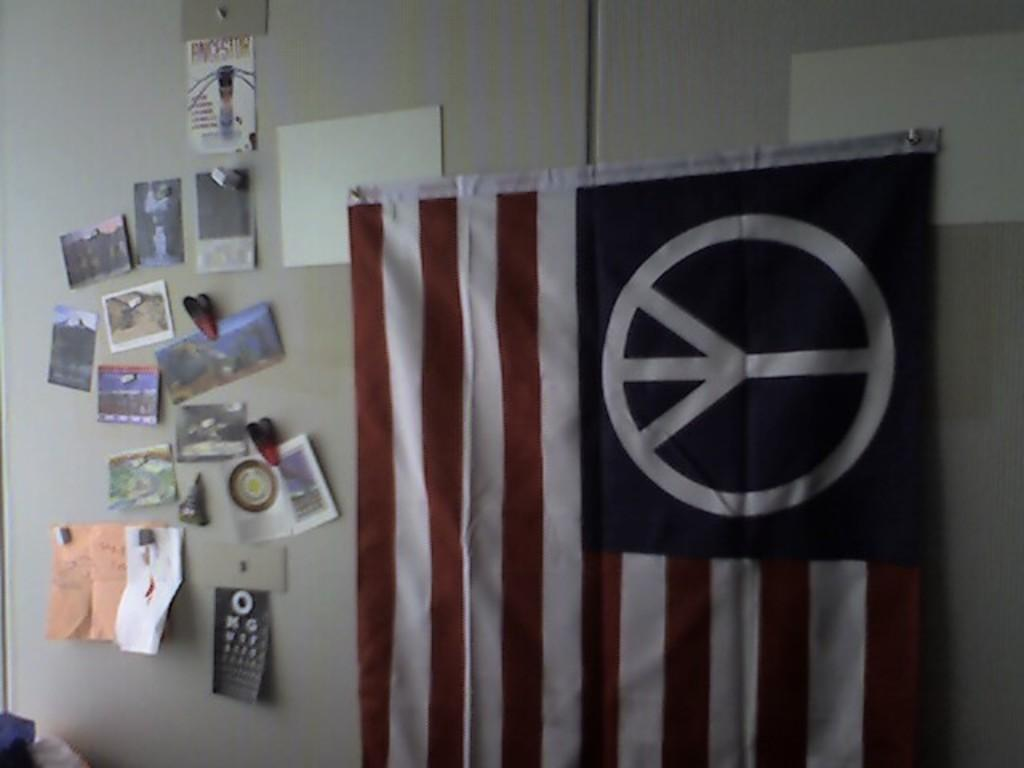What can be seen flying in the image? There is a flag in the image. What is attached to the wall in the image? There are photos and posters pinned to the wall. How many ducks are visible in the image? There are no ducks present in the image. What time of day is depicted in the image? The provided facts do not give any information about the time of day, so it cannot be determined from the image. 